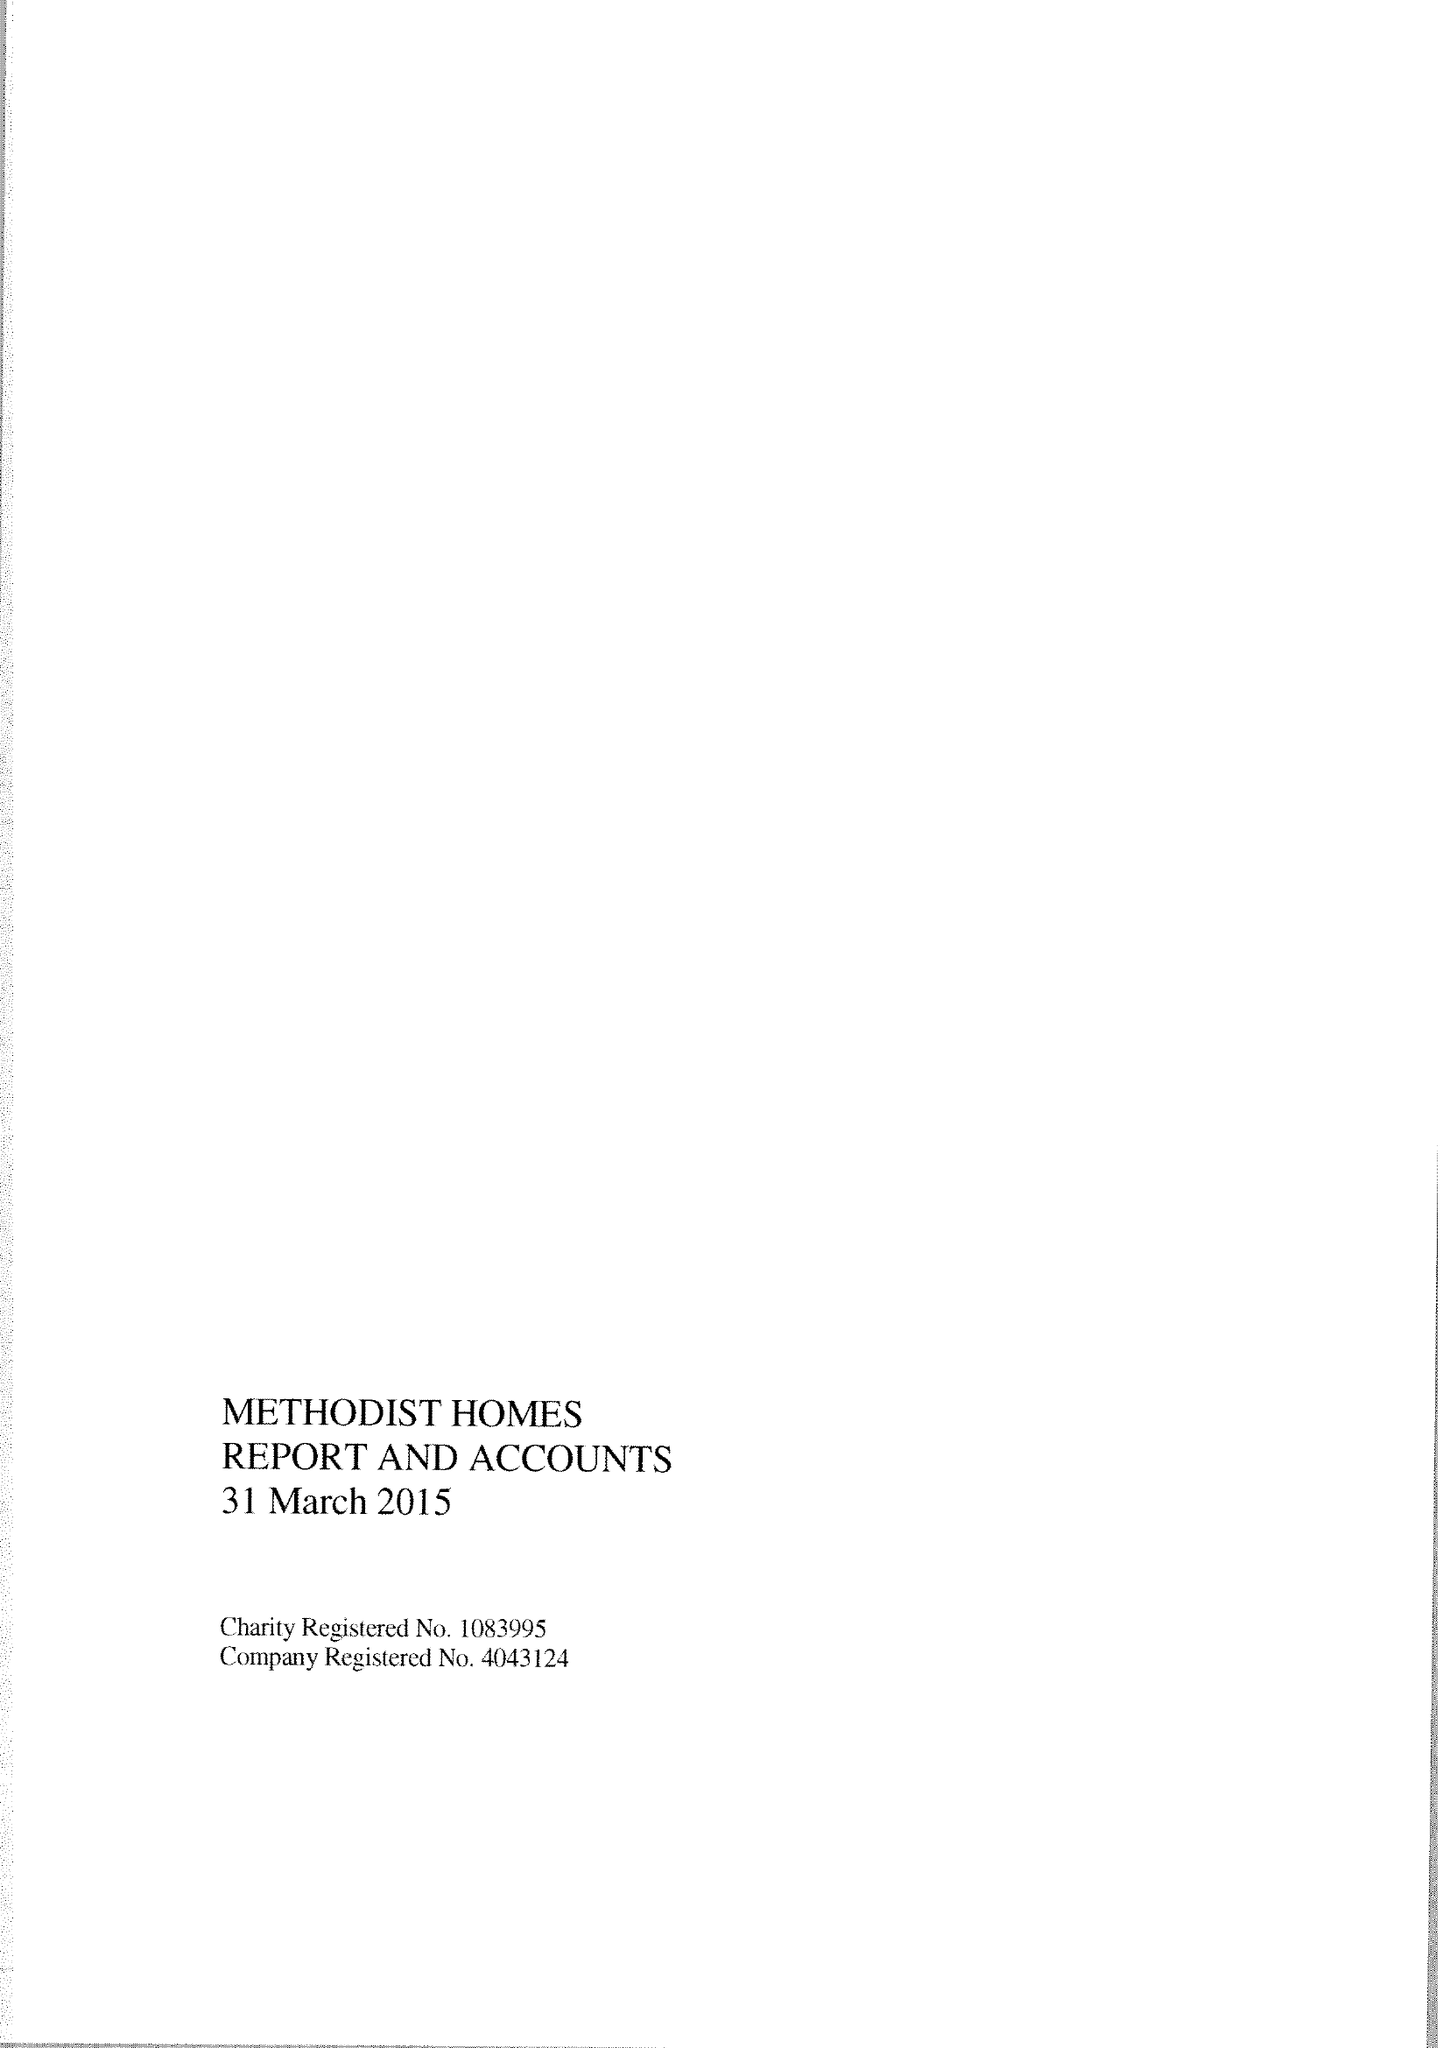What is the value for the charity_number?
Answer the question using a single word or phrase. 1083995 